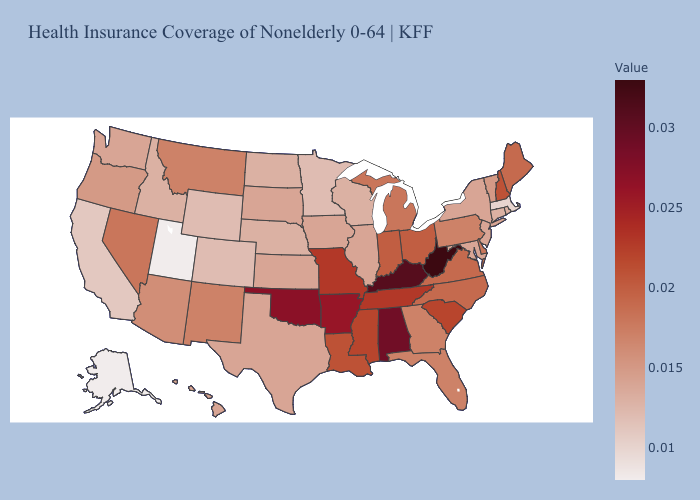Among the states that border Wyoming , does Montana have the highest value?
Keep it brief. Yes. Which states have the highest value in the USA?
Be succinct. West Virginia. Which states have the lowest value in the South?
Short answer required. Maryland, Texas. Does New Mexico have a higher value than South Dakota?
Be succinct. Yes. Does Massachusetts have the lowest value in the Northeast?
Give a very brief answer. Yes. 